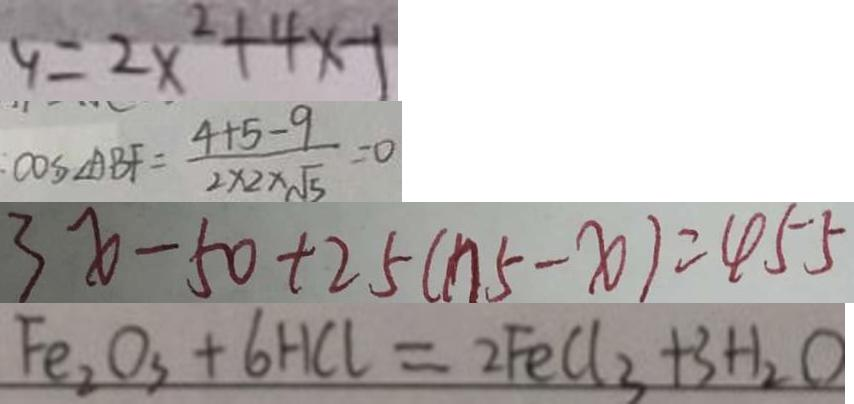<formula> <loc_0><loc_0><loc_500><loc_500>y = 2 x ^ { 2 } + 4 x - 1 
 : \cos \angle A B F = \frac { 4 + 5 - 9 } { 2 \times 2 \times \sqrt { 5 } } = 0 
 3 x - 5 0 + 2 5 ( n 5 - x ) = 4 5 5 
 F e _ { 2 } O _ { 3 } + 6 H C l = 2 F e C l _ { 3 } + 3 H _ { 2 } O</formula> 